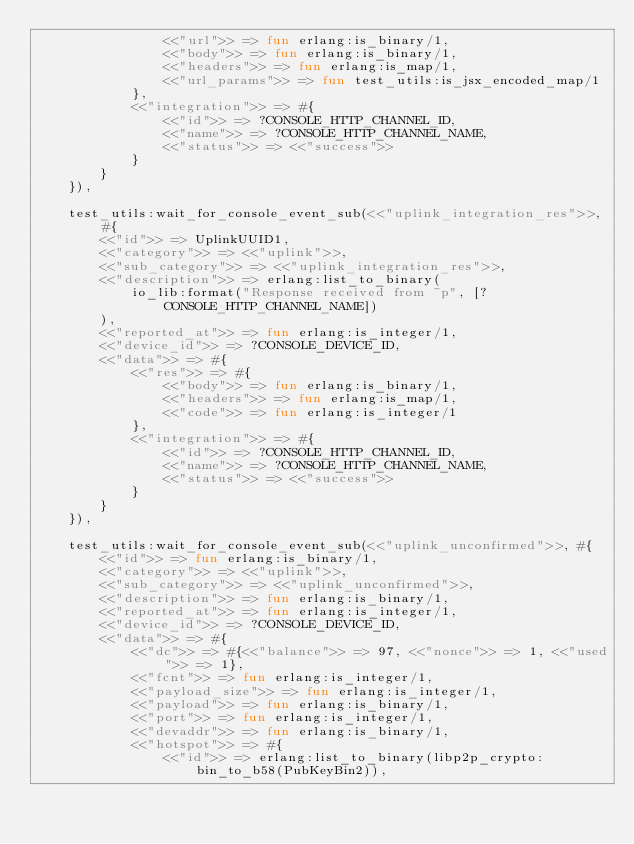Convert code to text. <code><loc_0><loc_0><loc_500><loc_500><_Erlang_>                <<"url">> => fun erlang:is_binary/1,
                <<"body">> => fun erlang:is_binary/1,
                <<"headers">> => fun erlang:is_map/1,
                <<"url_params">> => fun test_utils:is_jsx_encoded_map/1
            },
            <<"integration">> => #{
                <<"id">> => ?CONSOLE_HTTP_CHANNEL_ID,
                <<"name">> => ?CONSOLE_HTTP_CHANNEL_NAME,
                <<"status">> => <<"success">>
            }
        }
    }),

    test_utils:wait_for_console_event_sub(<<"uplink_integration_res">>, #{
        <<"id">> => UplinkUUID1,
        <<"category">> => <<"uplink">>,
        <<"sub_category">> => <<"uplink_integration_res">>,
        <<"description">> => erlang:list_to_binary(
            io_lib:format("Response received from ~p", [?CONSOLE_HTTP_CHANNEL_NAME])
        ),
        <<"reported_at">> => fun erlang:is_integer/1,
        <<"device_id">> => ?CONSOLE_DEVICE_ID,
        <<"data">> => #{
            <<"res">> => #{
                <<"body">> => fun erlang:is_binary/1,
                <<"headers">> => fun erlang:is_map/1,
                <<"code">> => fun erlang:is_integer/1
            },
            <<"integration">> => #{
                <<"id">> => ?CONSOLE_HTTP_CHANNEL_ID,
                <<"name">> => ?CONSOLE_HTTP_CHANNEL_NAME,
                <<"status">> => <<"success">>
            }
        }
    }),

    test_utils:wait_for_console_event_sub(<<"uplink_unconfirmed">>, #{
        <<"id">> => fun erlang:is_binary/1,
        <<"category">> => <<"uplink">>,
        <<"sub_category">> => <<"uplink_unconfirmed">>,
        <<"description">> => fun erlang:is_binary/1,
        <<"reported_at">> => fun erlang:is_integer/1,
        <<"device_id">> => ?CONSOLE_DEVICE_ID,
        <<"data">> => #{
            <<"dc">> => #{<<"balance">> => 97, <<"nonce">> => 1, <<"used">> => 1},
            <<"fcnt">> => fun erlang:is_integer/1,
            <<"payload_size">> => fun erlang:is_integer/1,
            <<"payload">> => fun erlang:is_binary/1,
            <<"port">> => fun erlang:is_integer/1,
            <<"devaddr">> => fun erlang:is_binary/1,
            <<"hotspot">> => #{
                <<"id">> => erlang:list_to_binary(libp2p_crypto:bin_to_b58(PubKeyBin2)),</code> 